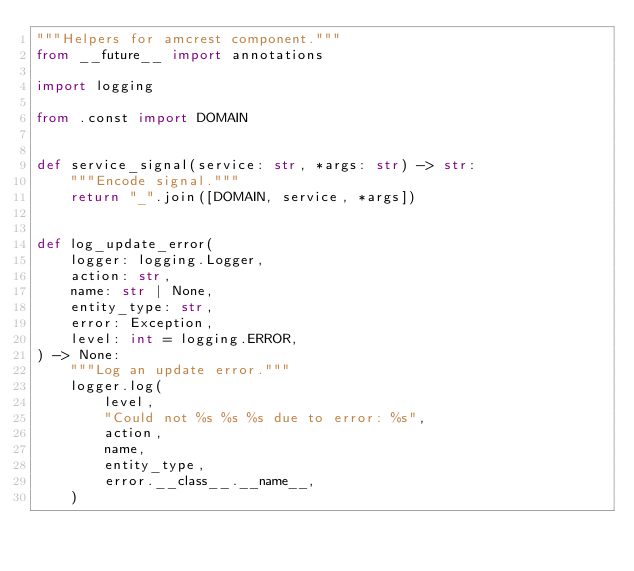Convert code to text. <code><loc_0><loc_0><loc_500><loc_500><_Python_>"""Helpers for amcrest component."""
from __future__ import annotations

import logging

from .const import DOMAIN


def service_signal(service: str, *args: str) -> str:
    """Encode signal."""
    return "_".join([DOMAIN, service, *args])


def log_update_error(
    logger: logging.Logger,
    action: str,
    name: str | None,
    entity_type: str,
    error: Exception,
    level: int = logging.ERROR,
) -> None:
    """Log an update error."""
    logger.log(
        level,
        "Could not %s %s %s due to error: %s",
        action,
        name,
        entity_type,
        error.__class__.__name__,
    )
</code> 